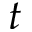<formula> <loc_0><loc_0><loc_500><loc_500>t</formula> 